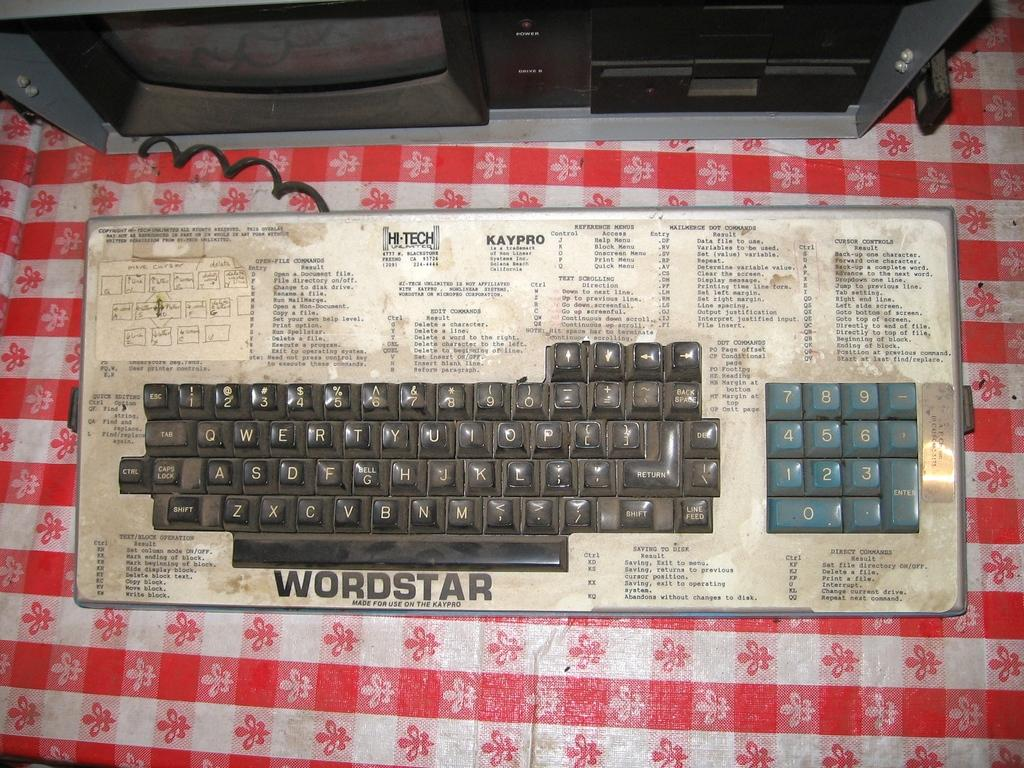Provide a one-sentence caption for the provided image. A dirty and grimy old keyboard is labeled with the term Wordstar. 